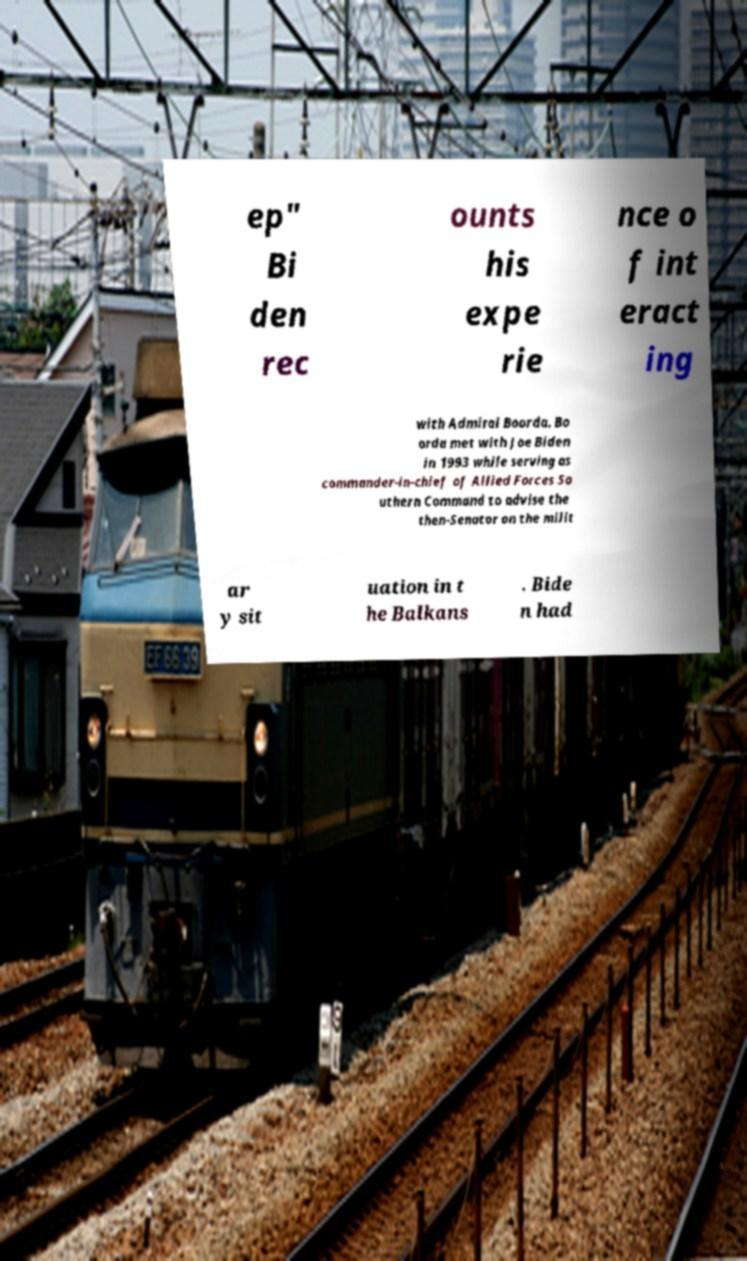There's text embedded in this image that I need extracted. Can you transcribe it verbatim? ep" Bi den rec ounts his expe rie nce o f int eract ing with Admiral Boorda. Bo orda met with Joe Biden in 1993 while serving as commander-in-chief of Allied Forces So uthern Command to advise the then-Senator on the milit ar y sit uation in t he Balkans . Bide n had 